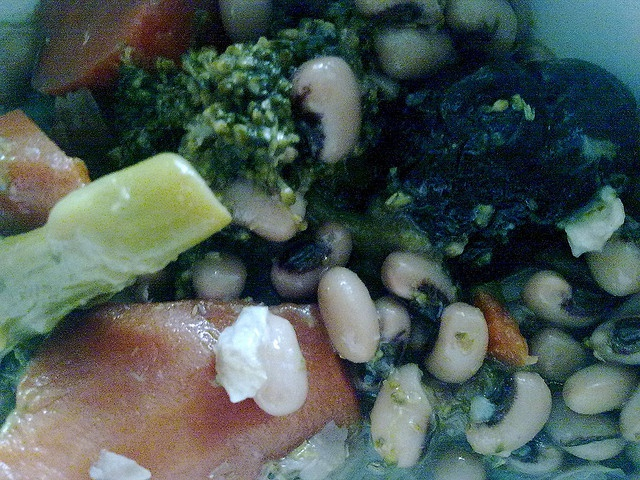Describe the objects in this image and their specific colors. I can see broccoli in teal, black, navy, and darkgreen tones, broccoli in teal, darkgray, olive, green, and lightgreen tones, broccoli in teal, black, and darkgreen tones, and broccoli in teal, black, darkgreen, and darkblue tones in this image. 